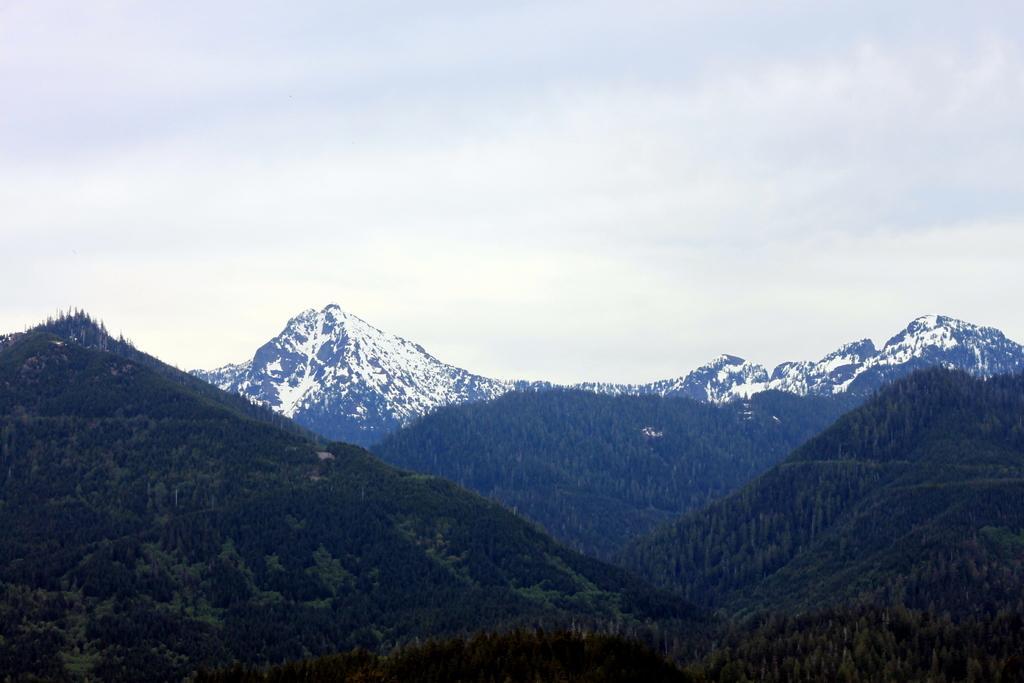Please provide a concise description of this image. In this image in the foreground and background there are trees and mountains, at the top of the image there is sky. 